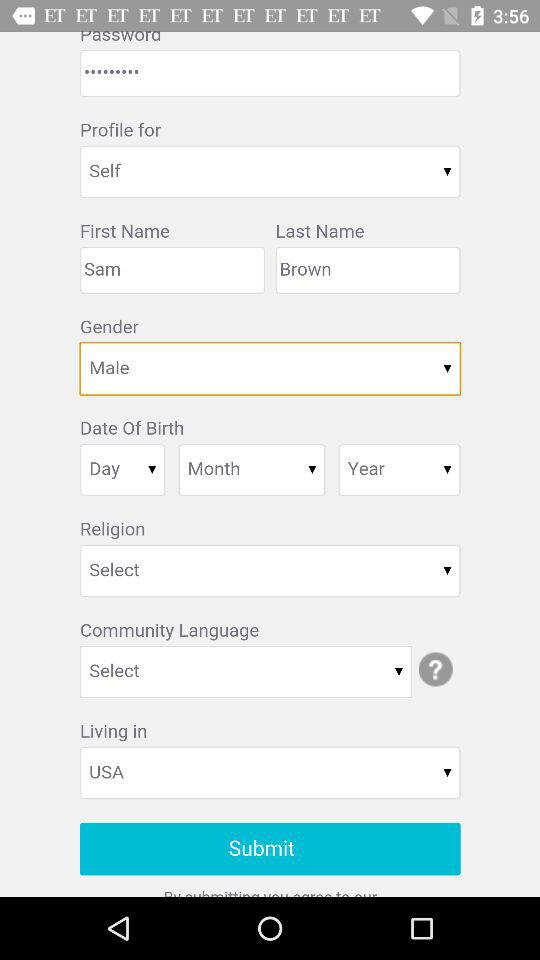What country does Sam live in? The country is "USA". 